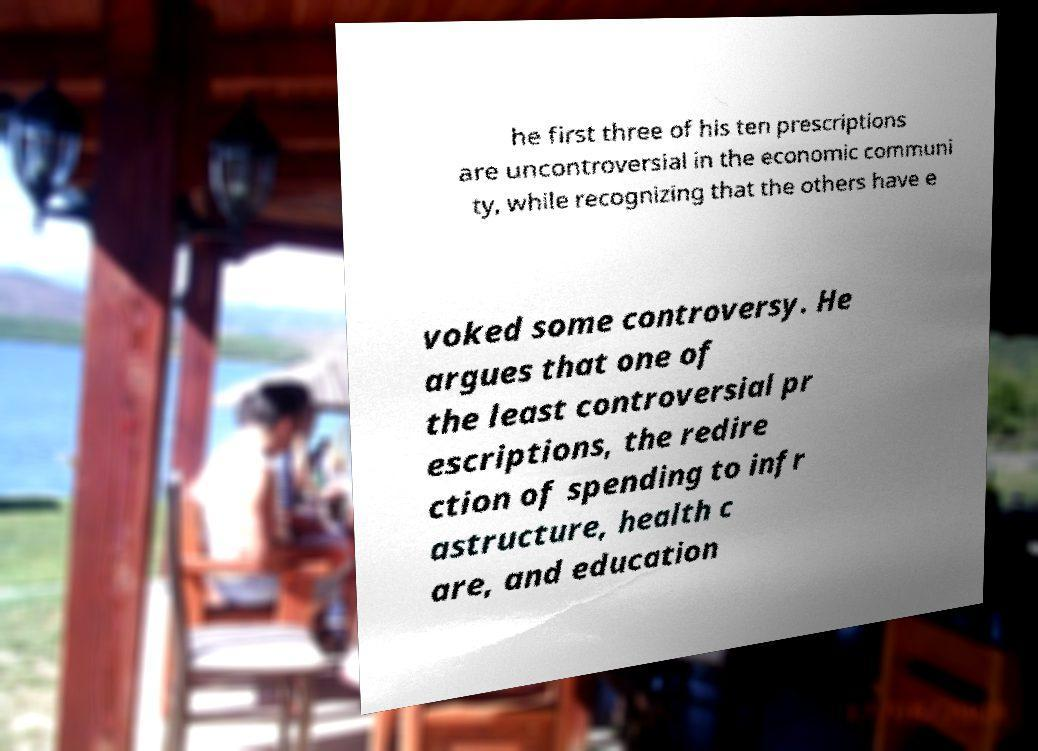Can you accurately transcribe the text from the provided image for me? he first three of his ten prescriptions are uncontroversial in the economic communi ty, while recognizing that the others have e voked some controversy. He argues that one of the least controversial pr escriptions, the redire ction of spending to infr astructure, health c are, and education 